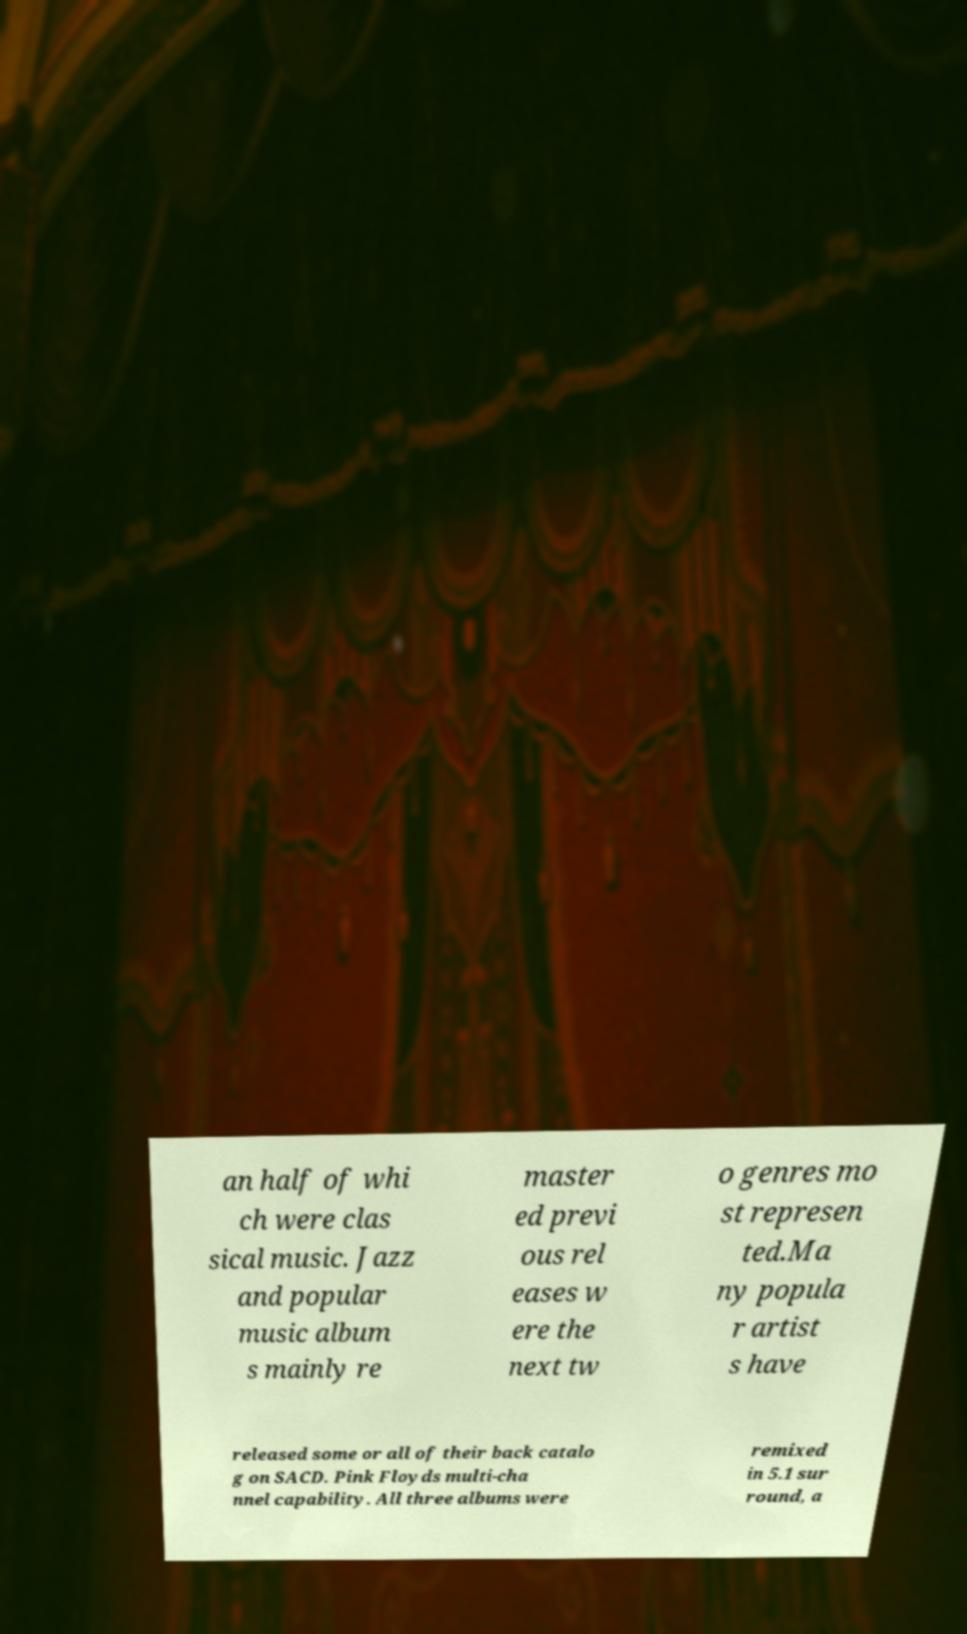Please read and relay the text visible in this image. What does it say? an half of whi ch were clas sical music. Jazz and popular music album s mainly re master ed previ ous rel eases w ere the next tw o genres mo st represen ted.Ma ny popula r artist s have released some or all of their back catalo g on SACD. Pink Floyds multi-cha nnel capability. All three albums were remixed in 5.1 sur round, a 